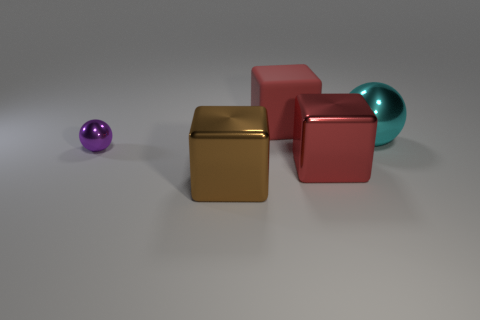Add 4 yellow metal cylinders. How many objects exist? 9 Subtract all red cubes. How many cubes are left? 1 Subtract all red blocks. How many blocks are left? 1 Subtract 0 yellow cylinders. How many objects are left? 5 Subtract all spheres. How many objects are left? 3 Subtract 1 balls. How many balls are left? 1 Subtract all gray cubes. Subtract all blue cylinders. How many cubes are left? 3 Subtract all cyan spheres. How many green cubes are left? 0 Subtract all large red rubber objects. Subtract all cyan metal objects. How many objects are left? 3 Add 4 big metallic objects. How many big metallic objects are left? 7 